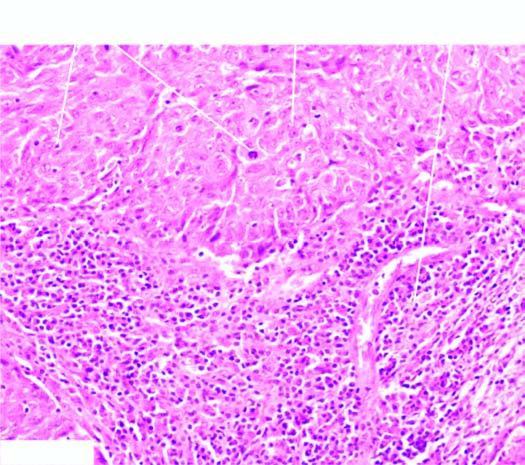what shows two characteristic features-large tumour cells forming syncytial arrangement and stroma infiltrated richly with lymphocytes?
Answer the question using a single word or phrase. Microscopy 